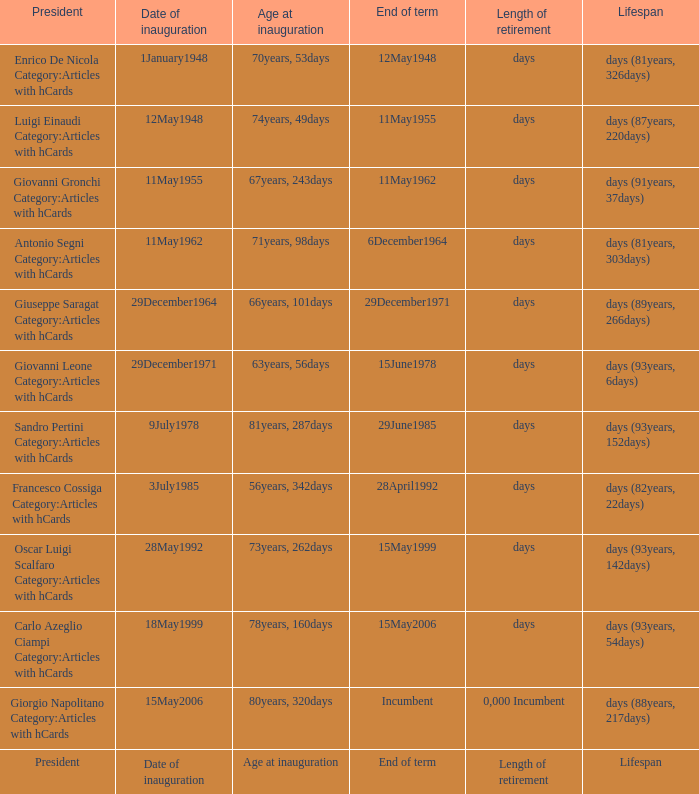On what date did the president, aged 73 years and 262 days, take office? 28May1992. 